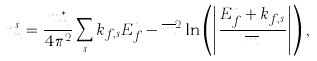Convert formula to latex. <formula><loc_0><loc_0><loc_500><loc_500>n ^ { s } _ { n } = \frac { m _ { n } ^ { * } } { 4 \pi ^ { 2 } } \sum _ { s } k _ { f , s } E _ { f } ^ { n } - \overline { m } ^ { 2 } \ln \left ( \left | \frac { E _ { f } ^ { n } + k _ { f , s } } { \overline { m } } \right | \right ) \, ,</formula> 